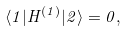<formula> <loc_0><loc_0><loc_500><loc_500>\langle { 1 } | H ^ { ( 1 ) } | { 2 } \rangle = 0 ,</formula> 